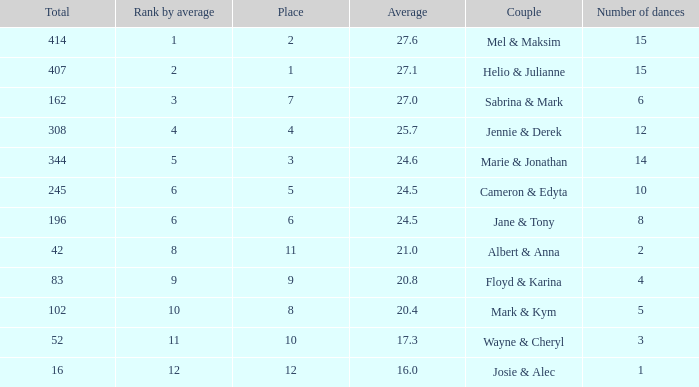What is the average place for a couple with the rank by average of 9 and total smaller than 83? None. 